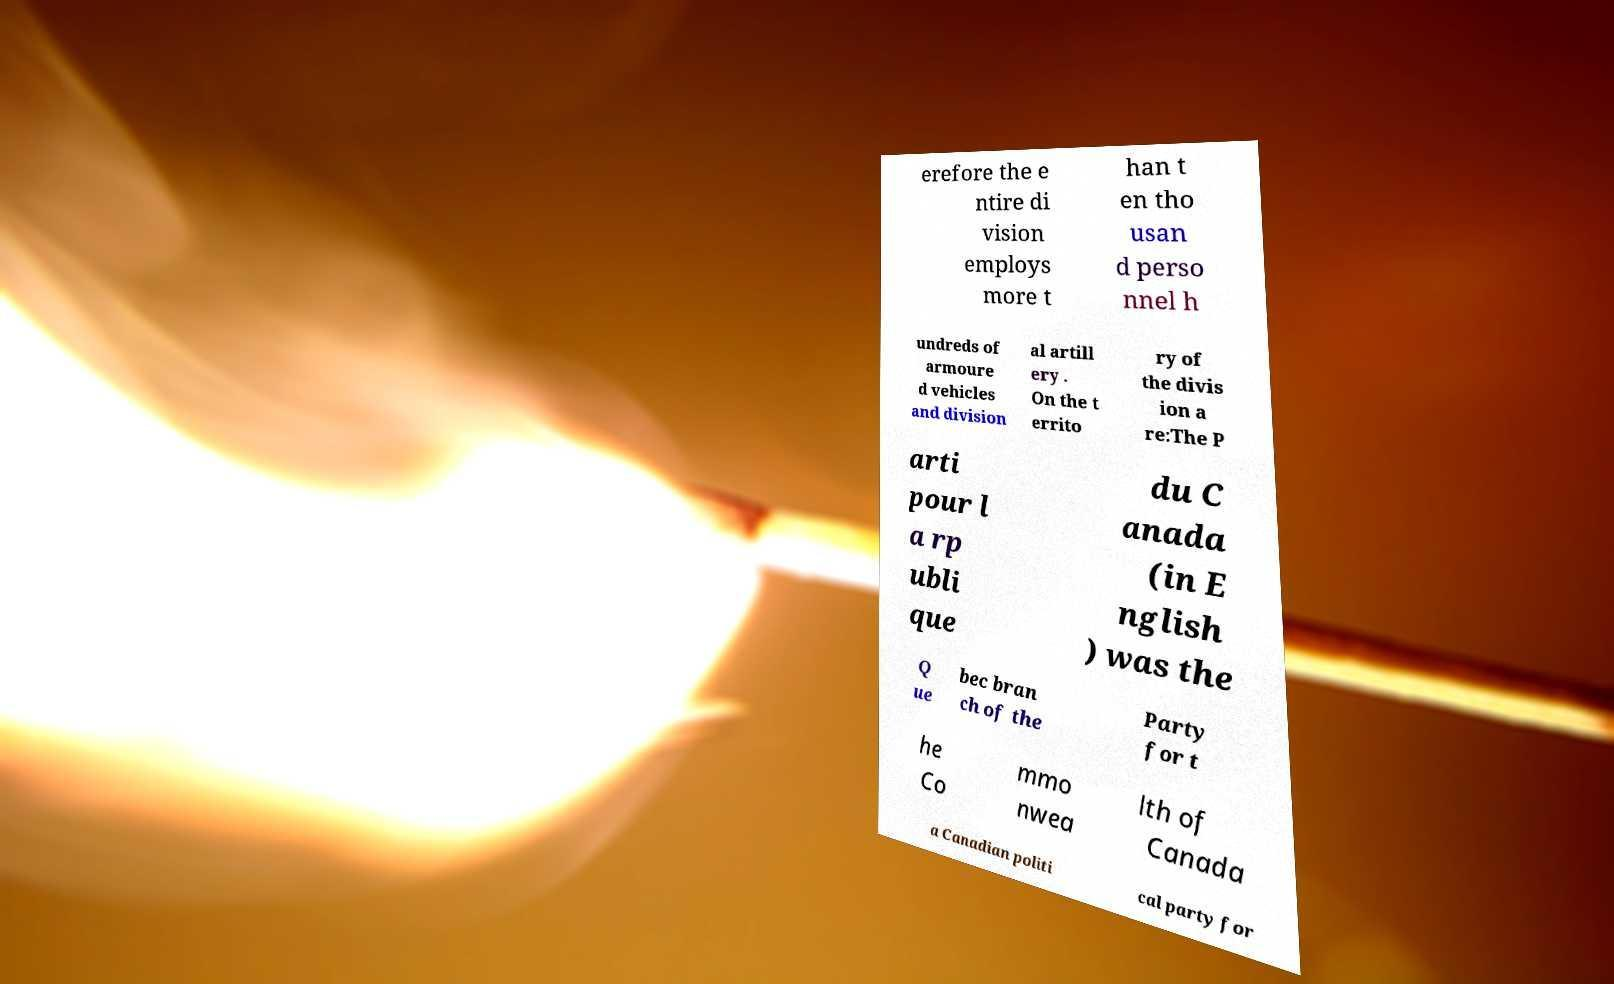What messages or text are displayed in this image? I need them in a readable, typed format. erefore the e ntire di vision employs more t han t en tho usan d perso nnel h undreds of armoure d vehicles and division al artill ery . On the t errito ry of the divis ion a re:The P arti pour l a rp ubli que du C anada (in E nglish ) was the Q ue bec bran ch of the Party for t he Co mmo nwea lth of Canada a Canadian politi cal party for 